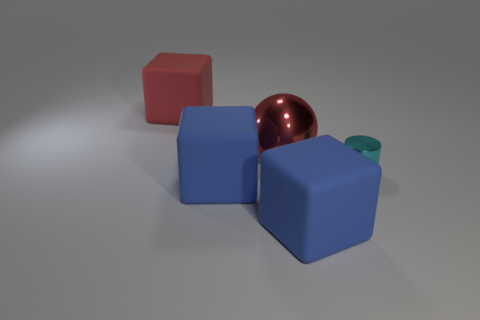Add 3 big blocks. How many objects exist? 8 Subtract all cubes. How many objects are left? 2 Subtract 0 brown spheres. How many objects are left? 5 Subtract all large rubber blocks. Subtract all small green objects. How many objects are left? 2 Add 5 big red matte things. How many big red matte things are left? 6 Add 5 cylinders. How many cylinders exist? 6 